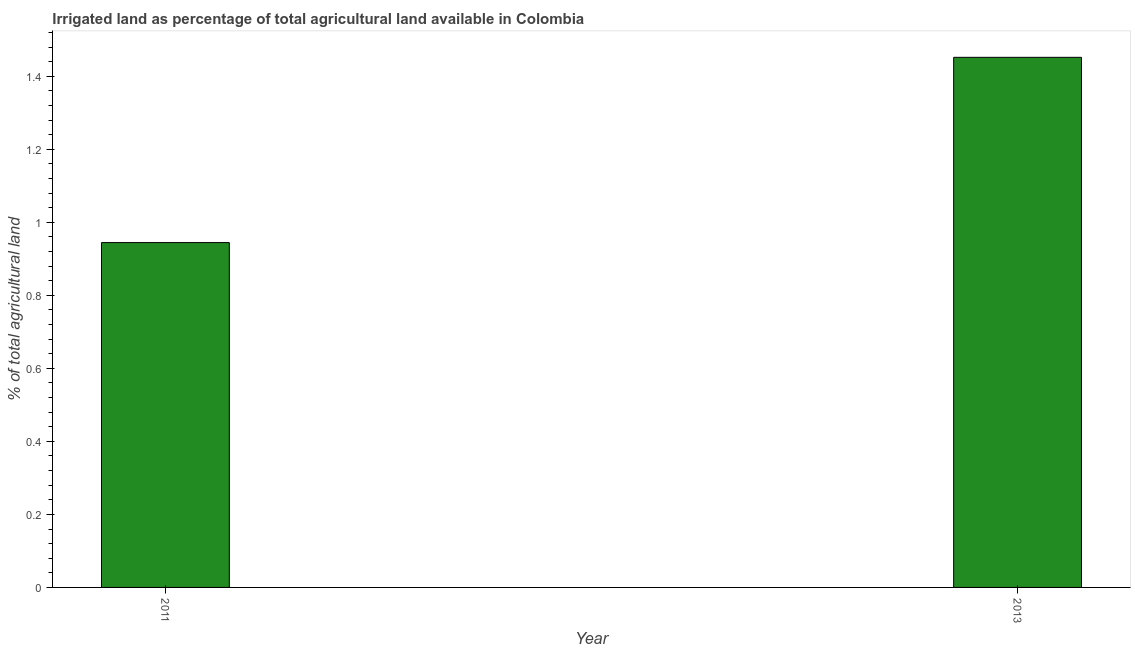Does the graph contain any zero values?
Offer a terse response. No. Does the graph contain grids?
Offer a terse response. No. What is the title of the graph?
Offer a very short reply. Irrigated land as percentage of total agricultural land available in Colombia. What is the label or title of the X-axis?
Ensure brevity in your answer.  Year. What is the label or title of the Y-axis?
Provide a short and direct response. % of total agricultural land. What is the percentage of agricultural irrigated land in 2011?
Offer a very short reply. 0.94. Across all years, what is the maximum percentage of agricultural irrigated land?
Give a very brief answer. 1.45. Across all years, what is the minimum percentage of agricultural irrigated land?
Give a very brief answer. 0.94. What is the sum of the percentage of agricultural irrigated land?
Offer a terse response. 2.4. What is the difference between the percentage of agricultural irrigated land in 2011 and 2013?
Keep it short and to the point. -0.51. What is the average percentage of agricultural irrigated land per year?
Ensure brevity in your answer.  1.2. What is the median percentage of agricultural irrigated land?
Your response must be concise. 1.2. In how many years, is the percentage of agricultural irrigated land greater than 0.36 %?
Offer a very short reply. 2. What is the ratio of the percentage of agricultural irrigated land in 2011 to that in 2013?
Your answer should be compact. 0.65. How many bars are there?
Ensure brevity in your answer.  2. Are all the bars in the graph horizontal?
Ensure brevity in your answer.  No. How many years are there in the graph?
Keep it short and to the point. 2. What is the difference between two consecutive major ticks on the Y-axis?
Give a very brief answer. 0.2. Are the values on the major ticks of Y-axis written in scientific E-notation?
Your answer should be very brief. No. What is the % of total agricultural land of 2011?
Your answer should be compact. 0.94. What is the % of total agricultural land of 2013?
Offer a terse response. 1.45. What is the difference between the % of total agricultural land in 2011 and 2013?
Give a very brief answer. -0.51. What is the ratio of the % of total agricultural land in 2011 to that in 2013?
Offer a very short reply. 0.65. 